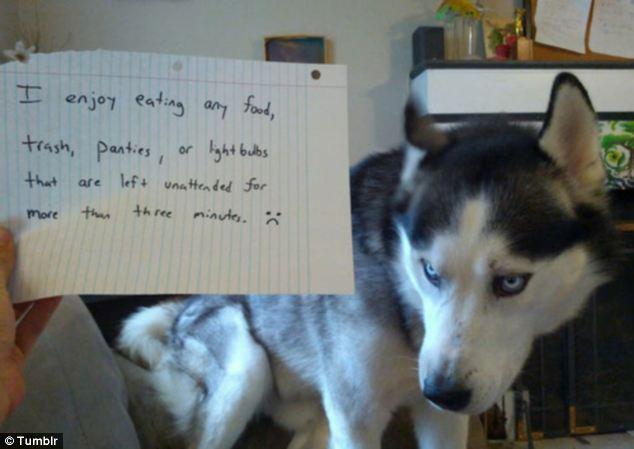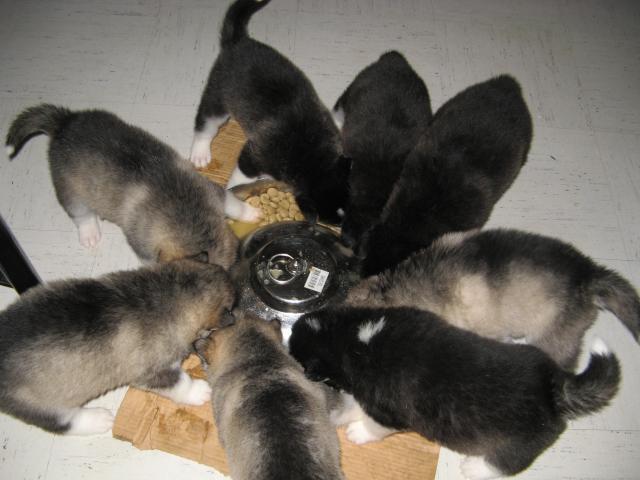The first image is the image on the left, the second image is the image on the right. Examine the images to the left and right. Is the description "A dog can be seen interacting with a severed limb portion of another animal." accurate? Answer yes or no. No. The first image is the image on the left, the second image is the image on the right. Assess this claim about the two images: "Each image shows a single husky dog, and one of the dogs pictured is in a reclining pose with its muzzle over a pinkish 'bone' and at least one paw near the object.". Correct or not? Answer yes or no. No. 